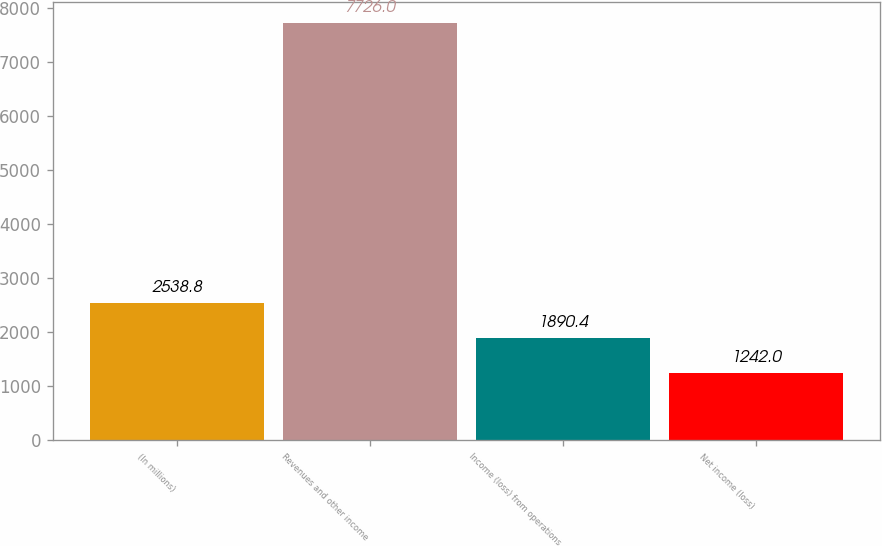<chart> <loc_0><loc_0><loc_500><loc_500><bar_chart><fcel>(In millions)<fcel>Revenues and other income<fcel>Income (loss) from operations<fcel>Net income (loss)<nl><fcel>2538.8<fcel>7726<fcel>1890.4<fcel>1242<nl></chart> 